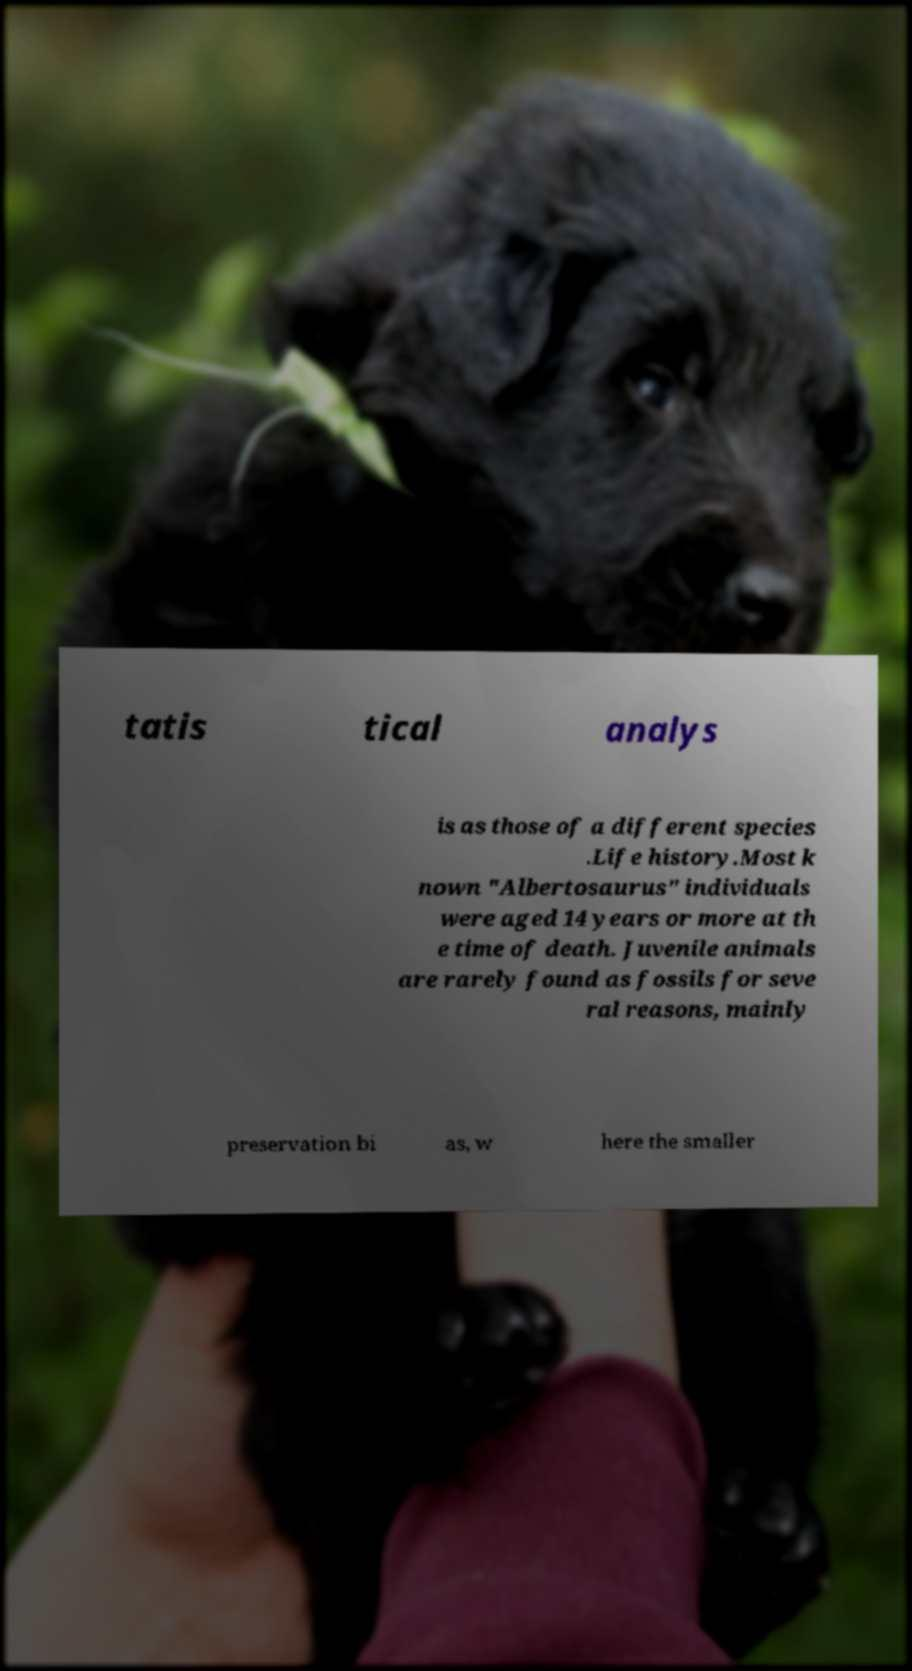What messages or text are displayed in this image? I need them in a readable, typed format. tatis tical analys is as those of a different species .Life history.Most k nown "Albertosaurus" individuals were aged 14 years or more at th e time of death. Juvenile animals are rarely found as fossils for seve ral reasons, mainly preservation bi as, w here the smaller 